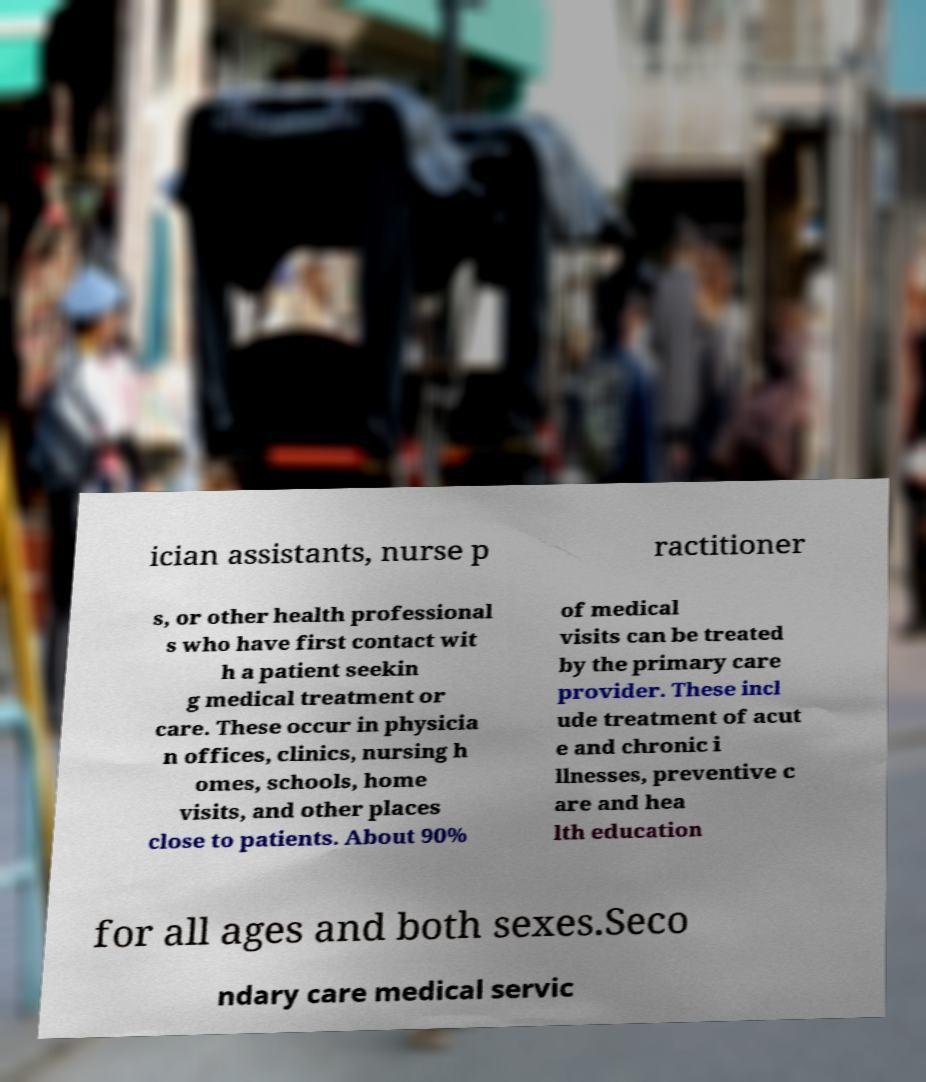I need the written content from this picture converted into text. Can you do that? ician assistants, nurse p ractitioner s, or other health professional s who have first contact wit h a patient seekin g medical treatment or care. These occur in physicia n offices, clinics, nursing h omes, schools, home visits, and other places close to patients. About 90% of medical visits can be treated by the primary care provider. These incl ude treatment of acut e and chronic i llnesses, preventive c are and hea lth education for all ages and both sexes.Seco ndary care medical servic 